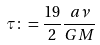<formula> <loc_0><loc_0><loc_500><loc_500>\tau \colon = \frac { 1 9 } { 2 } \frac { a \nu } { G M }</formula> 